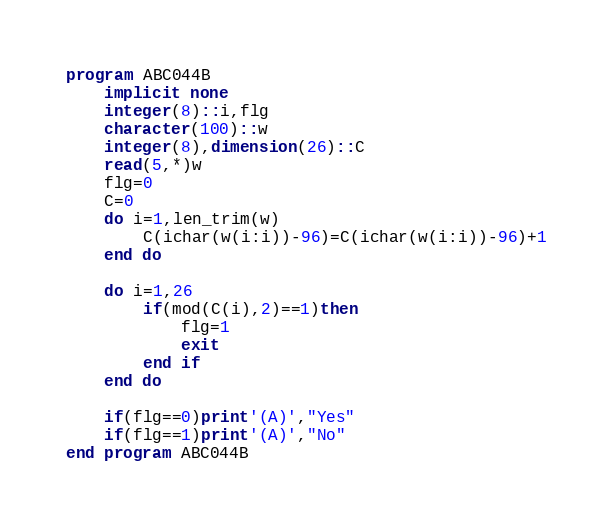<code> <loc_0><loc_0><loc_500><loc_500><_FORTRAN_>program ABC044B
    implicit none
    integer(8)::i,flg
    character(100)::w
    integer(8),dimension(26)::C
    read(5,*)w
    flg=0
    C=0
    do i=1,len_trim(w)
        C(ichar(w(i:i))-96)=C(ichar(w(i:i))-96)+1
    end do

    do i=1,26
        if(mod(C(i),2)==1)then
            flg=1
            exit
        end if
    end do

    if(flg==0)print'(A)',"Yes"
    if(flg==1)print'(A)',"No"
end program ABC044B</code> 